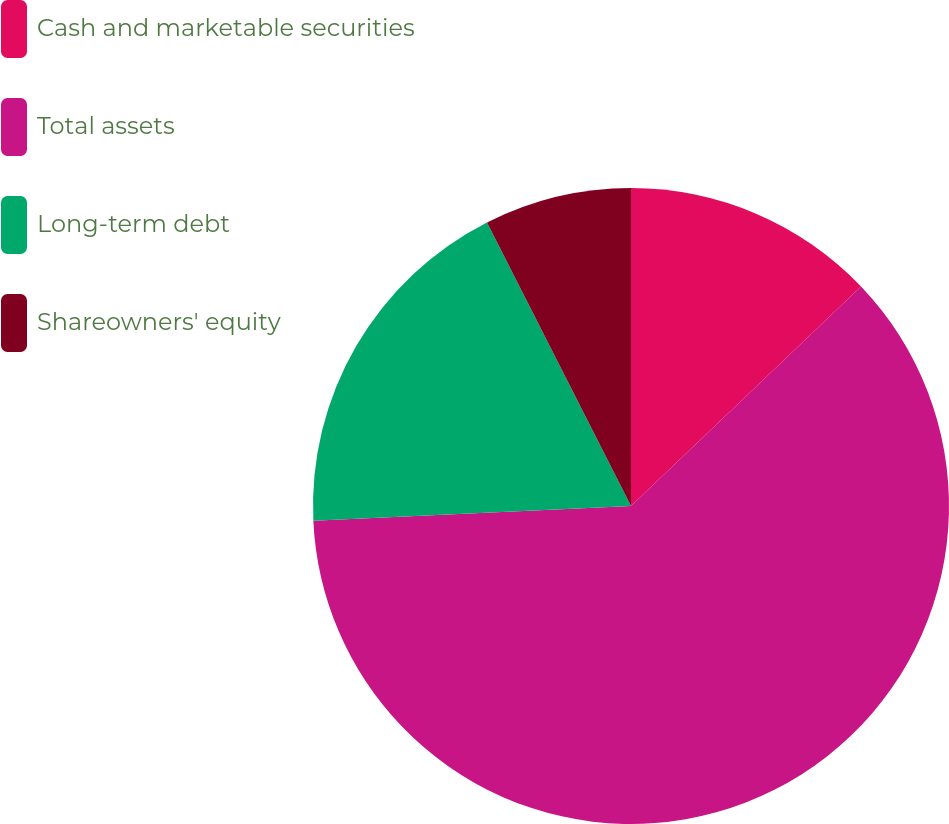<chart> <loc_0><loc_0><loc_500><loc_500><pie_chart><fcel>Cash and marketable securities<fcel>Total assets<fcel>Long-term debt<fcel>Shareowners' equity<nl><fcel>12.87%<fcel>61.39%<fcel>18.26%<fcel>7.48%<nl></chart> 